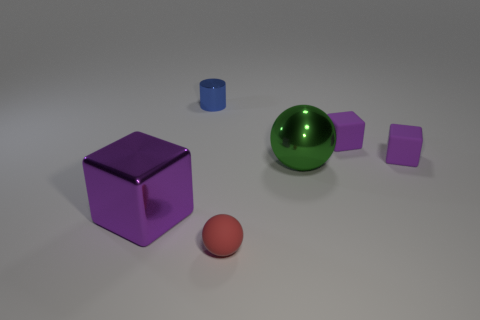Are there any tiny rubber objects of the same color as the tiny cylinder?
Provide a succinct answer. No. There is a cube that is left of the blue metallic cylinder; is there a tiny blue cylinder that is to the left of it?
Your response must be concise. No. Are there any big green things made of the same material as the big sphere?
Make the answer very short. No. What material is the sphere behind the small object in front of the big cube?
Make the answer very short. Metal. What material is the tiny thing that is both on the left side of the green metallic object and in front of the metallic cylinder?
Your answer should be compact. Rubber. Are there an equal number of small purple rubber cubes behind the large green object and tiny matte cubes?
Ensure brevity in your answer.  Yes. How many other large green metal things are the same shape as the large green object?
Give a very brief answer. 0. There is a ball behind the big shiny thing on the left side of the tiny red thing that is to the left of the green metal sphere; what is its size?
Your answer should be compact. Large. Do the tiny object on the left side of the small ball and the big green thing have the same material?
Your answer should be very brief. Yes. Is the number of metal blocks behind the metal sphere the same as the number of blue objects that are left of the blue cylinder?
Ensure brevity in your answer.  Yes. 